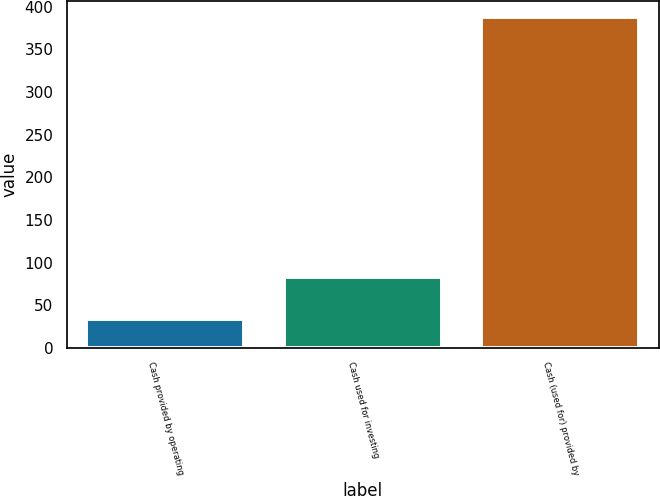<chart> <loc_0><loc_0><loc_500><loc_500><bar_chart><fcel>Cash provided by operating<fcel>Cash used for investing<fcel>Cash (used for) provided by<nl><fcel>34<fcel>83<fcel>388<nl></chart> 